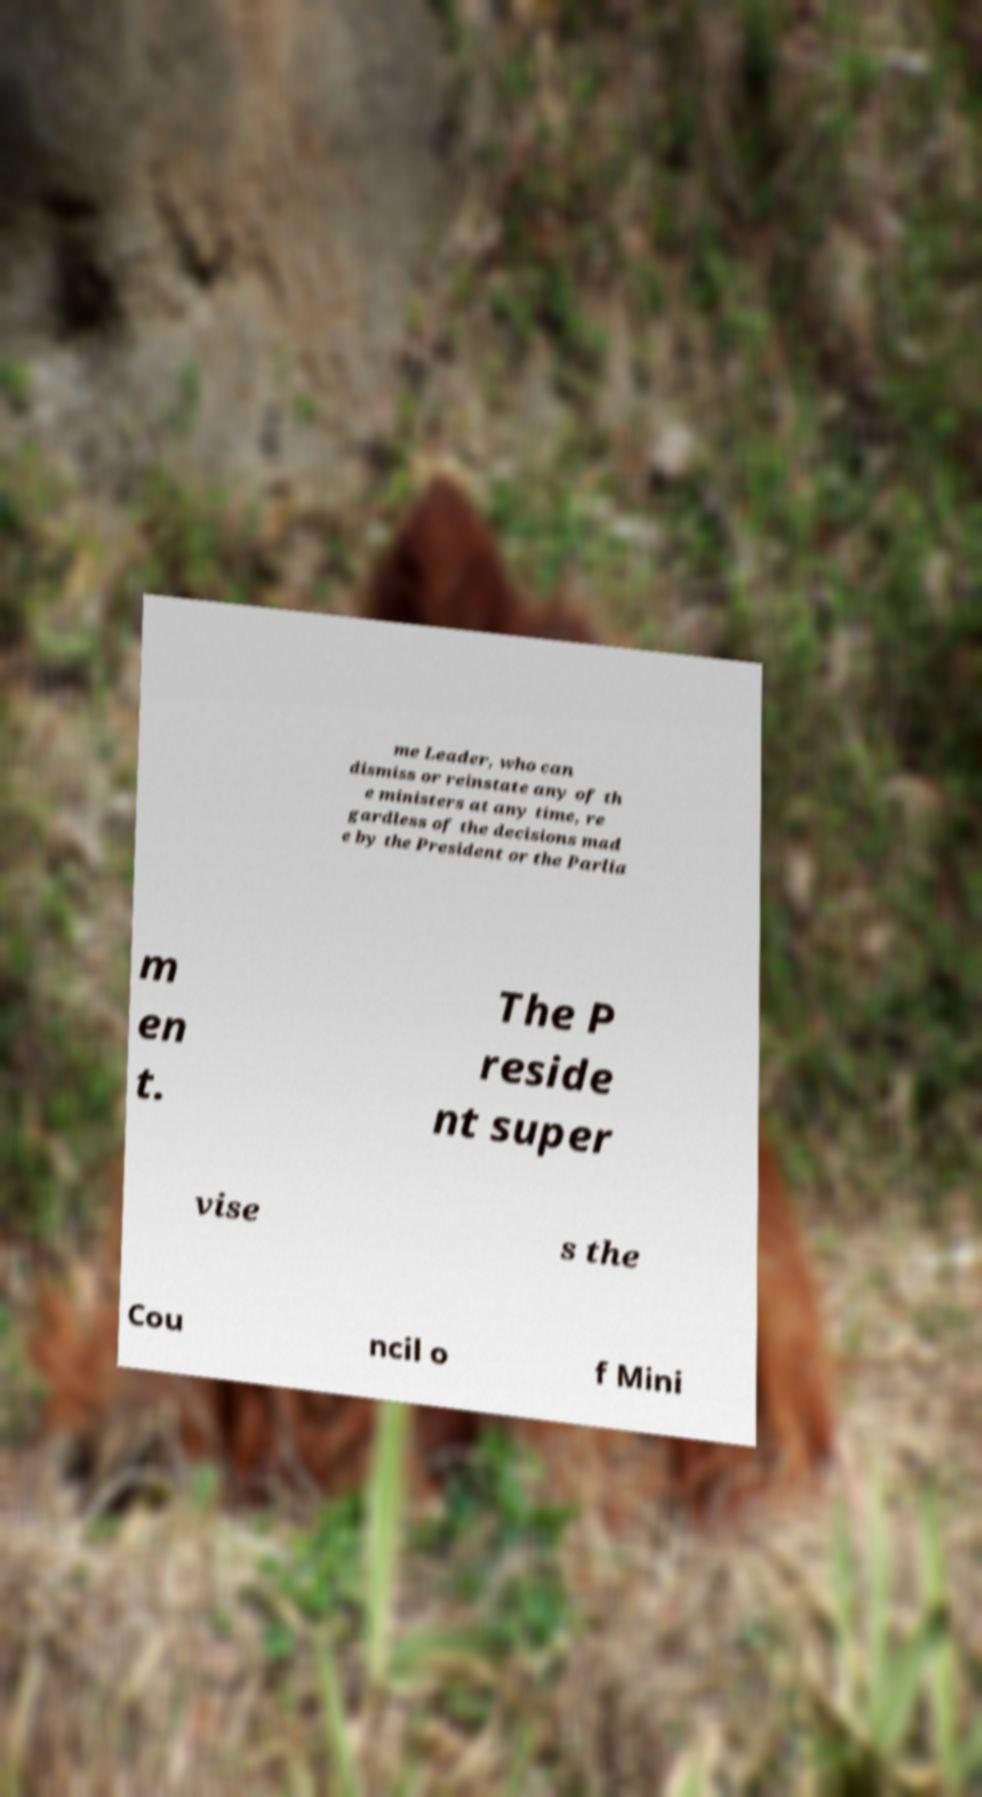Could you extract and type out the text from this image? me Leader, who can dismiss or reinstate any of th e ministers at any time, re gardless of the decisions mad e by the President or the Parlia m en t. The P reside nt super vise s the Cou ncil o f Mini 